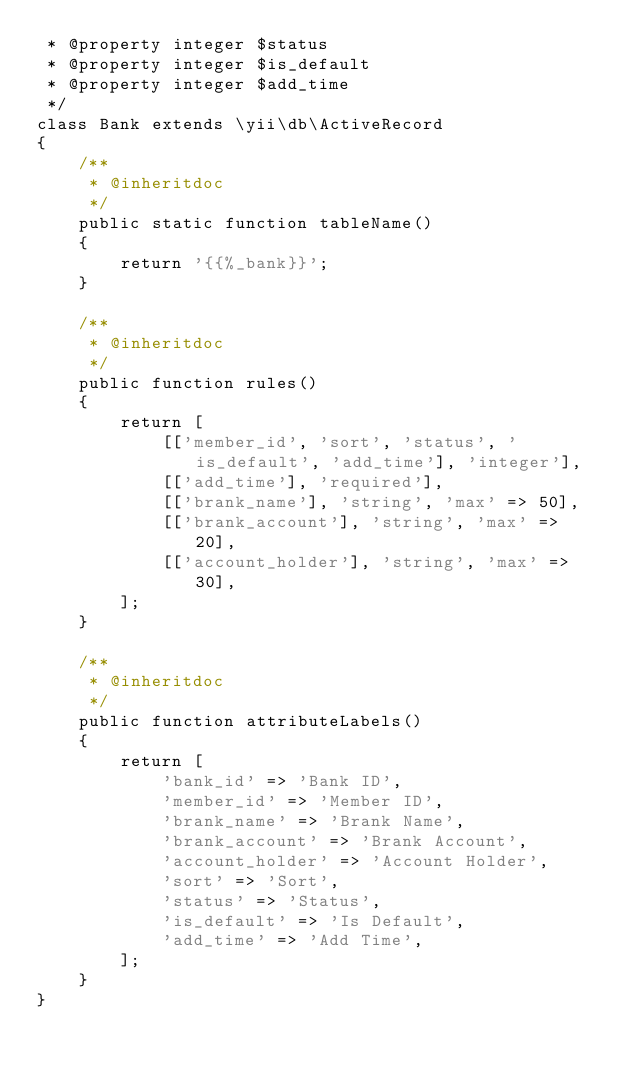Convert code to text. <code><loc_0><loc_0><loc_500><loc_500><_PHP_> * @property integer $status
 * @property integer $is_default
 * @property integer $add_time
 */
class Bank extends \yii\db\ActiveRecord
{
    /**
     * @inheritdoc
     */
    public static function tableName()
    {
        return '{{%_bank}}';
    }

    /**
     * @inheritdoc
     */
    public function rules()
    {
        return [
            [['member_id', 'sort', 'status', 'is_default', 'add_time'], 'integer'],
            [['add_time'], 'required'],
            [['brank_name'], 'string', 'max' => 50],
            [['brank_account'], 'string', 'max' => 20],
            [['account_holder'], 'string', 'max' => 30],
        ];
    }

    /**
     * @inheritdoc
     */
    public function attributeLabels()
    {
        return [
            'bank_id' => 'Bank ID',
            'member_id' => 'Member ID',
            'brank_name' => 'Brank Name',
            'brank_account' => 'Brank Account',
            'account_holder' => 'Account Holder',
            'sort' => 'Sort',
            'status' => 'Status',
            'is_default' => 'Is Default',
            'add_time' => 'Add Time',
        ];
    }
}
</code> 